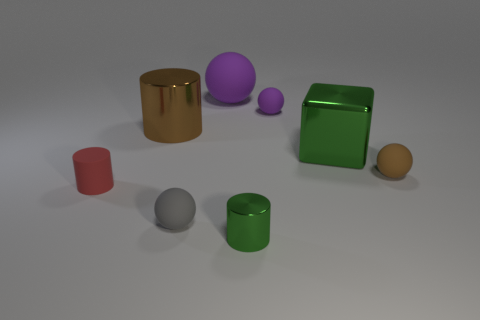What materials do the objects in the image appear to be made of? The objects in the image seem to have different materials. The shiny gold and green objects might be made of a metallic material given their reflective surfaces. The red and purple objects have a matte finish, suggesting they could be made of rubber or plastic. 